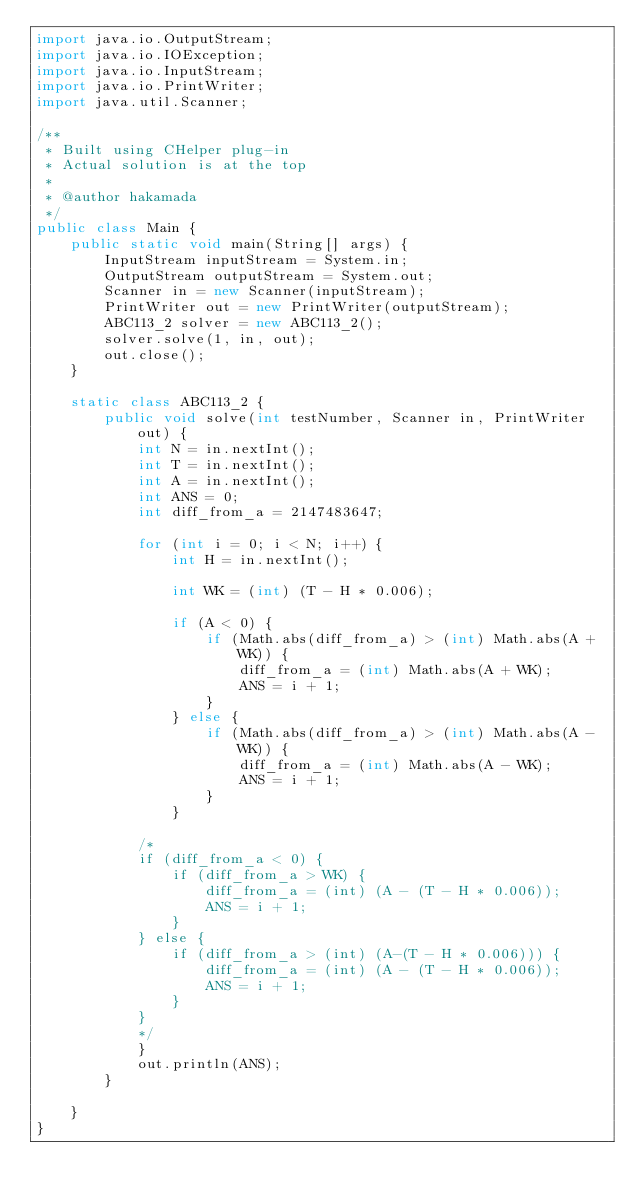Convert code to text. <code><loc_0><loc_0><loc_500><loc_500><_Java_>import java.io.OutputStream;
import java.io.IOException;
import java.io.InputStream;
import java.io.PrintWriter;
import java.util.Scanner;

/**
 * Built using CHelper plug-in
 * Actual solution is at the top
 *
 * @author hakamada
 */
public class Main {
    public static void main(String[] args) {
        InputStream inputStream = System.in;
        OutputStream outputStream = System.out;
        Scanner in = new Scanner(inputStream);
        PrintWriter out = new PrintWriter(outputStream);
        ABC113_2 solver = new ABC113_2();
        solver.solve(1, in, out);
        out.close();
    }

    static class ABC113_2 {
        public void solve(int testNumber, Scanner in, PrintWriter out) {
            int N = in.nextInt();
            int T = in.nextInt();
            int A = in.nextInt();
            int ANS = 0;
            int diff_from_a = 2147483647;

            for (int i = 0; i < N; i++) {
                int H = in.nextInt();

                int WK = (int) (T - H * 0.006);

                if (A < 0) {
                    if (Math.abs(diff_from_a) > (int) Math.abs(A + WK)) {
                        diff_from_a = (int) Math.abs(A + WK);
                        ANS = i + 1;
                    }
                } else {
                    if (Math.abs(diff_from_a) > (int) Math.abs(A - WK)) {
                        diff_from_a = (int) Math.abs(A - WK);
                        ANS = i + 1;
                    }
                }

            /*
            if (diff_from_a < 0) {
                if (diff_from_a > WK) {
                    diff_from_a = (int) (A - (T - H * 0.006));
                    ANS = i + 1;
                }
            } else {
                if (diff_from_a > (int) (A-(T - H * 0.006))) {
                    diff_from_a = (int) (A - (T - H * 0.006));
                    ANS = i + 1;
                }
            }
            */
            }
            out.println(ANS);
        }

    }
}

</code> 